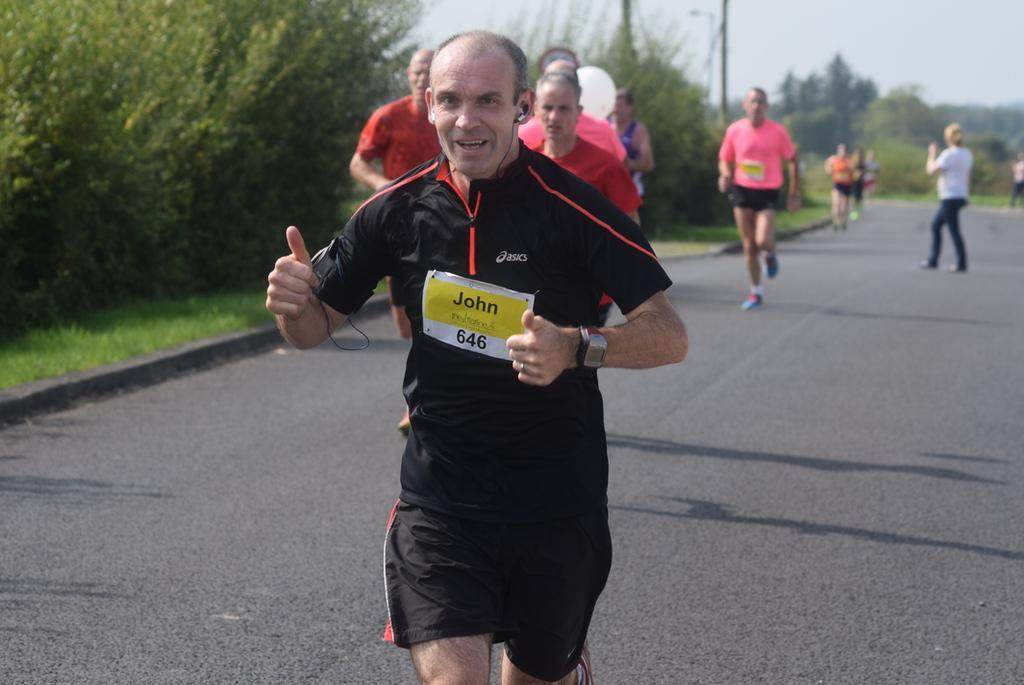How many people are in the image? There are people in the image, but the exact number is not specified. What are some of the people doing in the image? Some people are standing, and some are running in the image. Where are the people located in the image? The people are on a road in the image. What can be seen in the background of the image? In the background of the image, there are trees, grass, and the sky. What is the rule for folding the trees in the image? There is no rule for folding trees in the image, as trees are not objects that can be folded. 